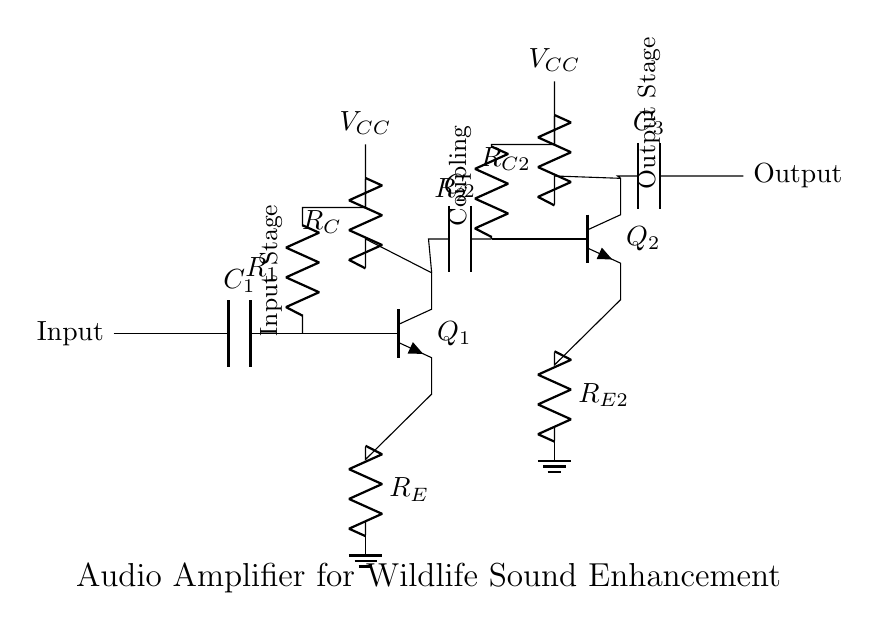What is the name of the first transistor in this circuit? The first transistor is labeled as Q1 in the diagram, indicating it is the primary transistor used in the input stage of the amplifier.
Answer: Q1 What type of components are used for coupling in this circuit? The circuit contains capacitors (C2 and C3) for coupling. Capacitors are commonly used in amplifier circuits to pass AC signals while blocking DC voltage, thus allowing audio signals to be processed.
Answer: Capacitors What is the purpose of the resistor labeled R_E? Resistor R_E is referred to as the emitter resistor, which is used to stabilize the operating point of the transistor Q1 by providing negative feedback. This improves linearity and ensures consistent performance across variations in temperature and transistor characteristics.
Answer: Stabilization What is the voltage supply for this audio amplifier circuit? The voltage supply is indicated as V_CC, which is connected at two points in the circuit, providing the necessary power for both the input and output stages of the amplifier.
Answer: V_CC How many stages are there in this audio amplifier circuit? The circuit has two distinct amplification stages, indicated by the connections and components associated with each transistor, Q1 and Q2. Each stage amplifies the audio signal further for increased gain.
Answer: Two What does the component labeled C_1 do at the input stage? Capacitor C_1 acts as a coupling capacitor that allows AC signals (audio) from the input source to pass through while blocking any DC component, ensuring that only the desired audio frequencies are amplified.
Answer: Coupling What is the output connection in this circuit? The output connection is represented as a node at the end of the circuit, indicated by the label "Output," where the amplified audio signal is taken from the final stage of amplification.
Answer: Output 